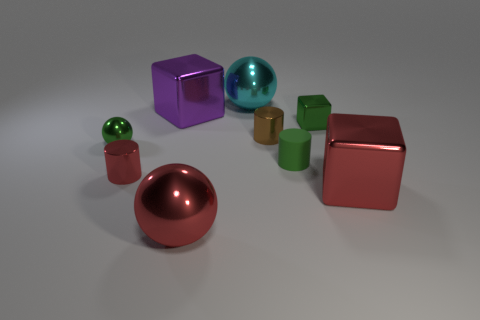What color is the object that is both in front of the tiny green cylinder and to the left of the big purple metal cube?
Your answer should be very brief. Red. Does the brown metal cylinder have the same size as the purple metallic cube?
Keep it short and to the point. No. There is a block that is in front of the tiny red cylinder; what is its color?
Your answer should be compact. Red. Is there a large thing of the same color as the tiny sphere?
Provide a short and direct response. No. What color is the other ball that is the same size as the cyan metallic ball?
Keep it short and to the point. Red. Does the small brown thing have the same shape as the green matte thing?
Your response must be concise. Yes. There is a big ball that is behind the tiny block; what material is it?
Offer a very short reply. Metal. The small metal ball is what color?
Offer a terse response. Green. Is the size of the metal ball behind the tiny metallic cube the same as the metallic cube to the left of the small brown cylinder?
Your response must be concise. Yes. There is a cube that is behind the small red object and to the right of the brown metal thing; what is its size?
Offer a terse response. Small. 